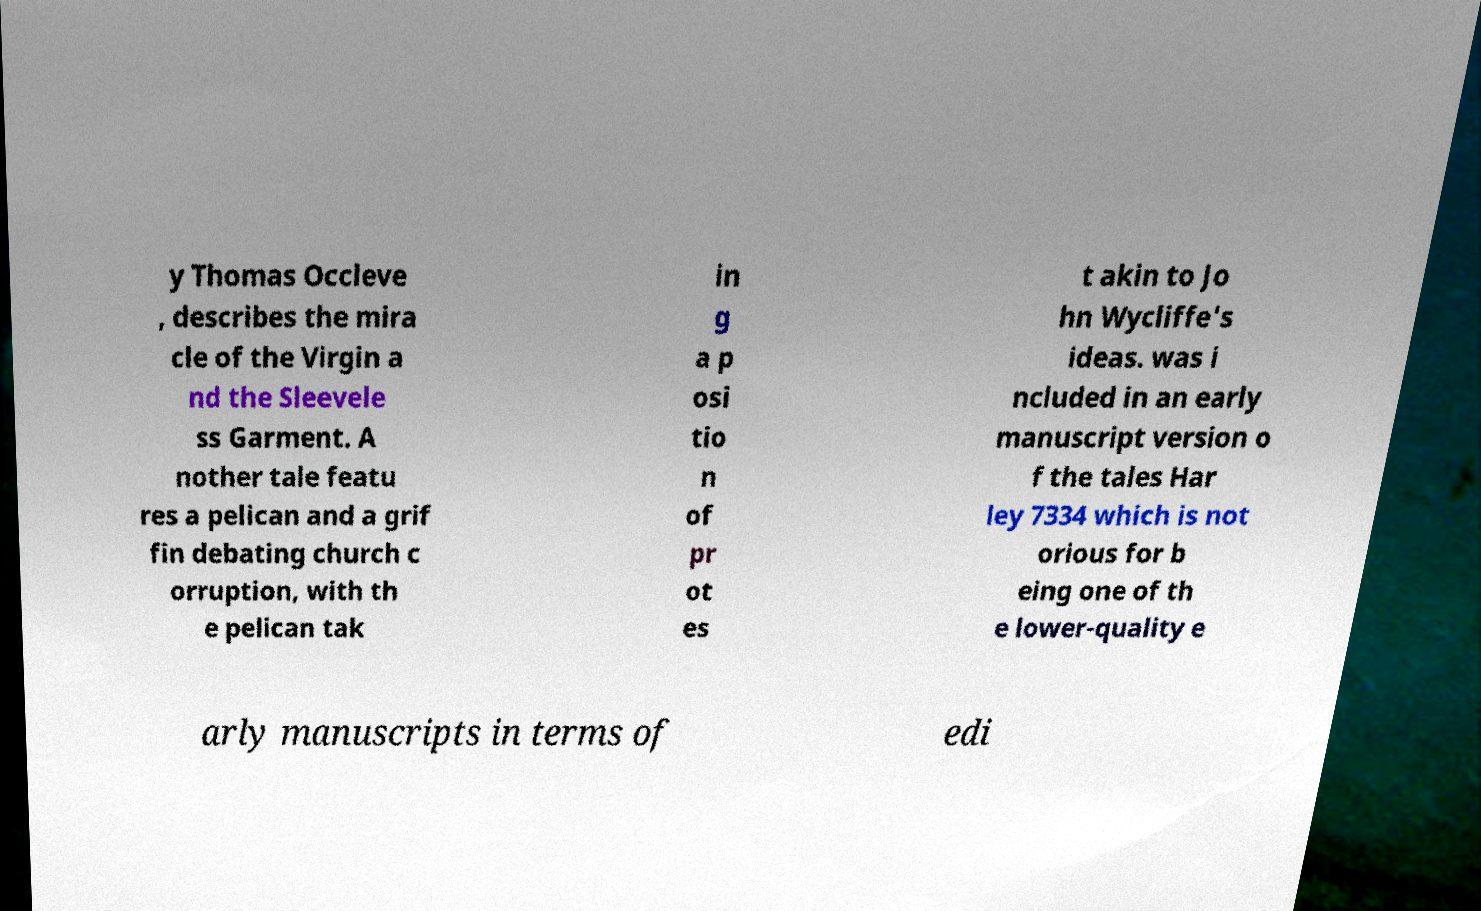I need the written content from this picture converted into text. Can you do that? y Thomas Occleve , describes the mira cle of the Virgin a nd the Sleevele ss Garment. A nother tale featu res a pelican and a grif fin debating church c orruption, with th e pelican tak in g a p osi tio n of pr ot es t akin to Jo hn Wycliffe's ideas. was i ncluded in an early manuscript version o f the tales Har ley 7334 which is not orious for b eing one of th e lower-quality e arly manuscripts in terms of edi 